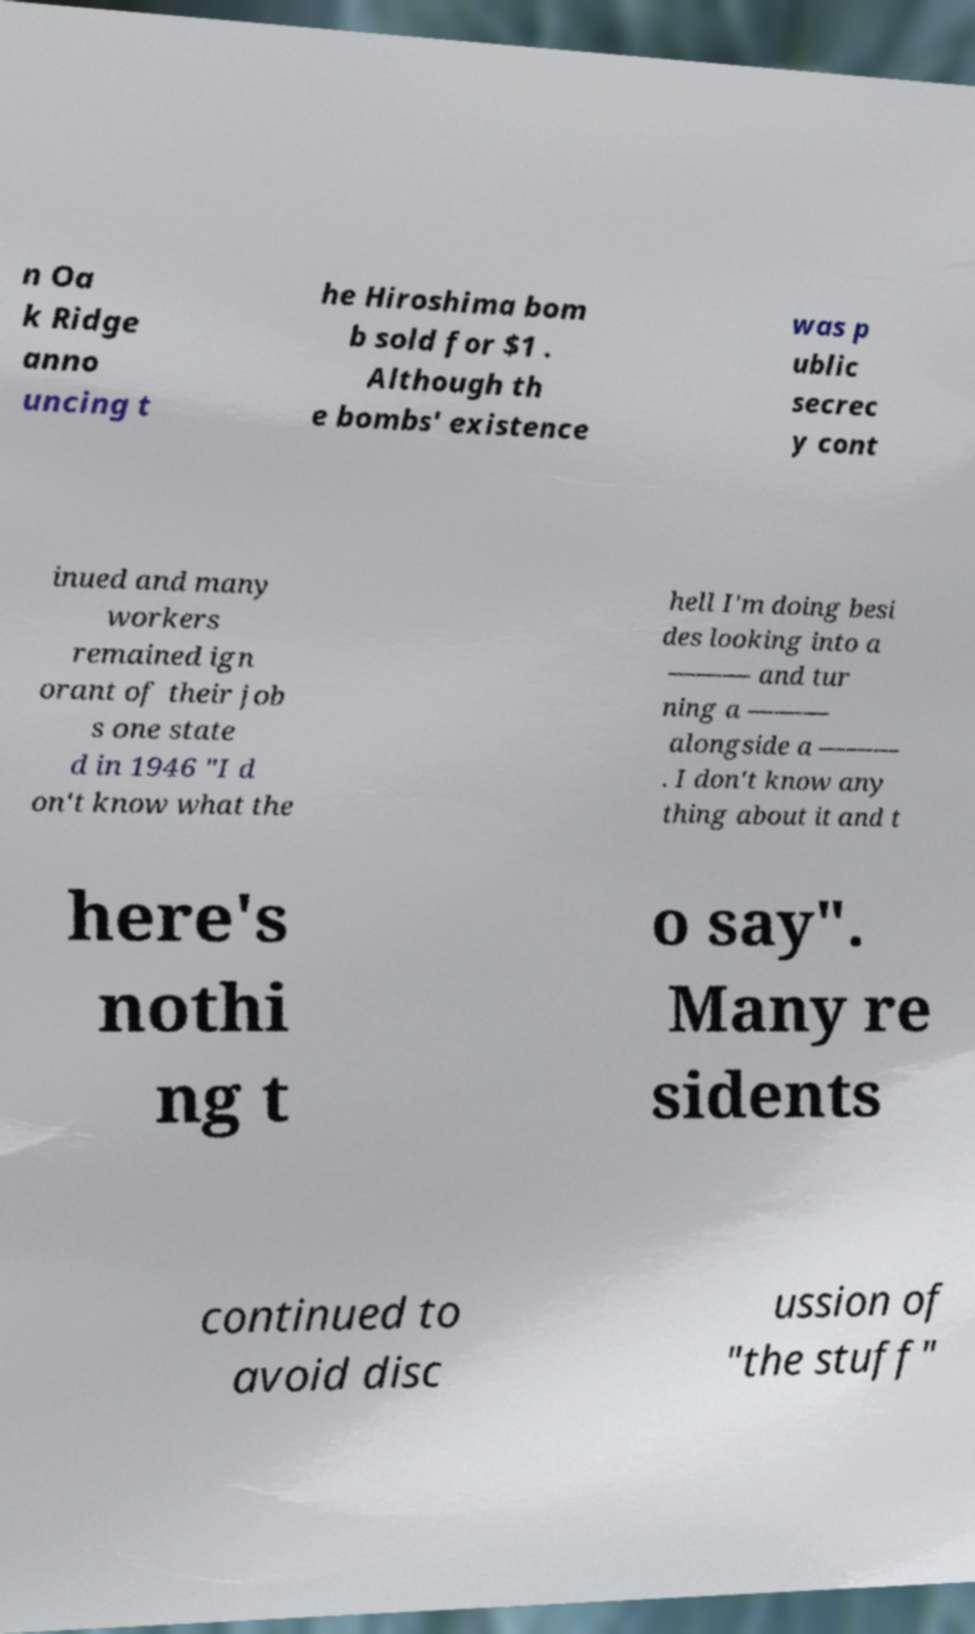Please identify and transcribe the text found in this image. n Oa k Ridge anno uncing t he Hiroshima bom b sold for $1 . Although th e bombs' existence was p ublic secrec y cont inued and many workers remained ign orant of their job s one state d in 1946 "I d on't know what the hell I'm doing besi des looking into a ——— and tur ning a ——— alongside a ——— . I don't know any thing about it and t here's nothi ng t o say". Many re sidents continued to avoid disc ussion of "the stuff" 